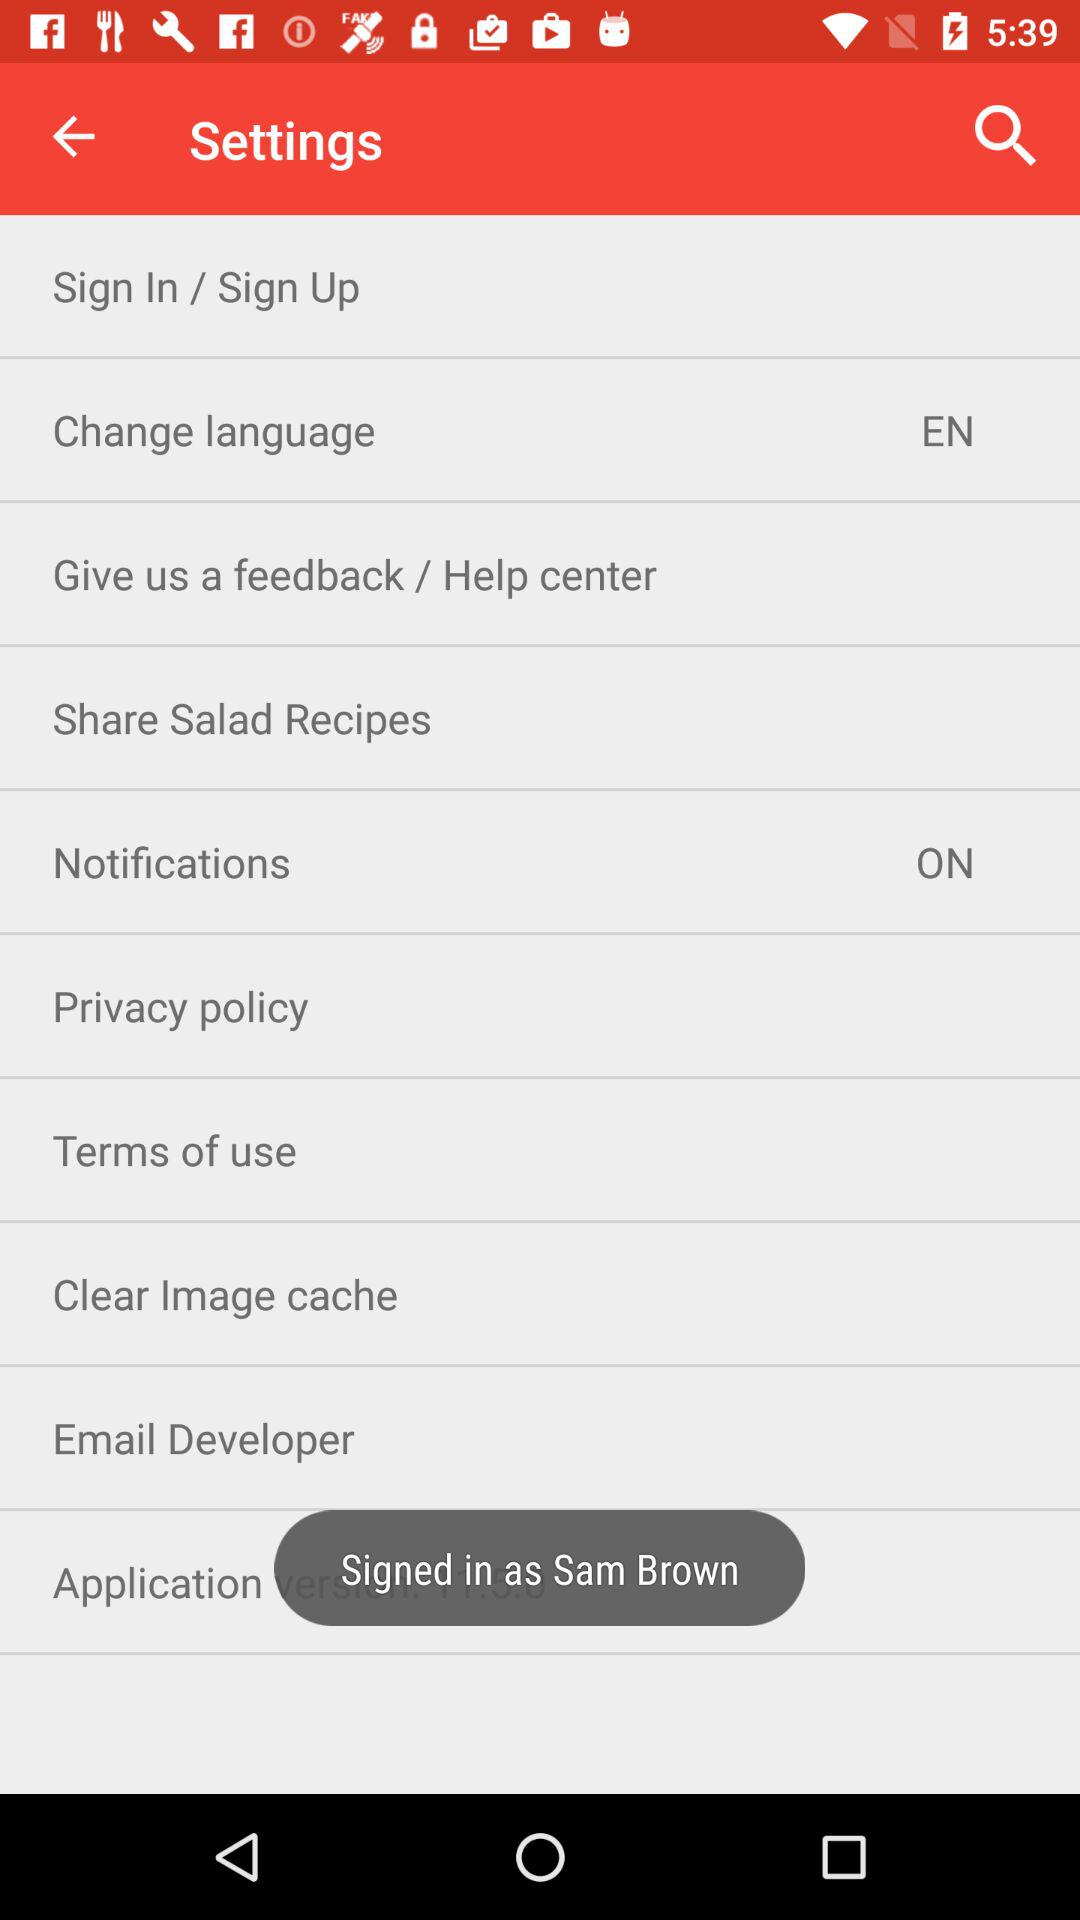Which language has been selected? The selected language is English. 